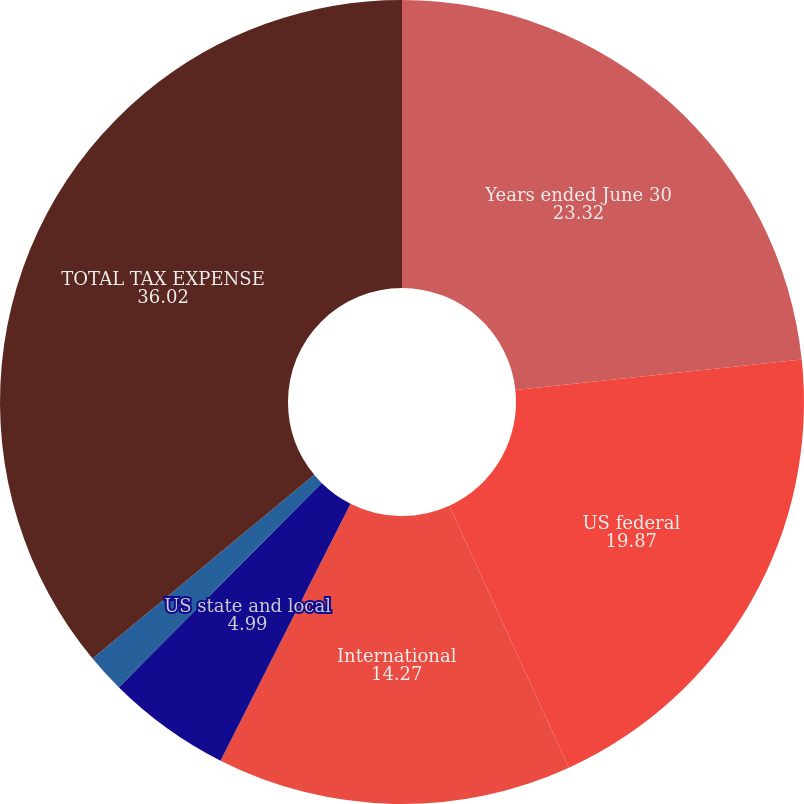Convert chart to OTSL. <chart><loc_0><loc_0><loc_500><loc_500><pie_chart><fcel>Years ended June 30<fcel>US federal<fcel>International<fcel>US state and local<fcel>International and other<fcel>TOTAL TAX EXPENSE<nl><fcel>23.32%<fcel>19.87%<fcel>14.27%<fcel>4.99%<fcel>1.54%<fcel>36.02%<nl></chart> 